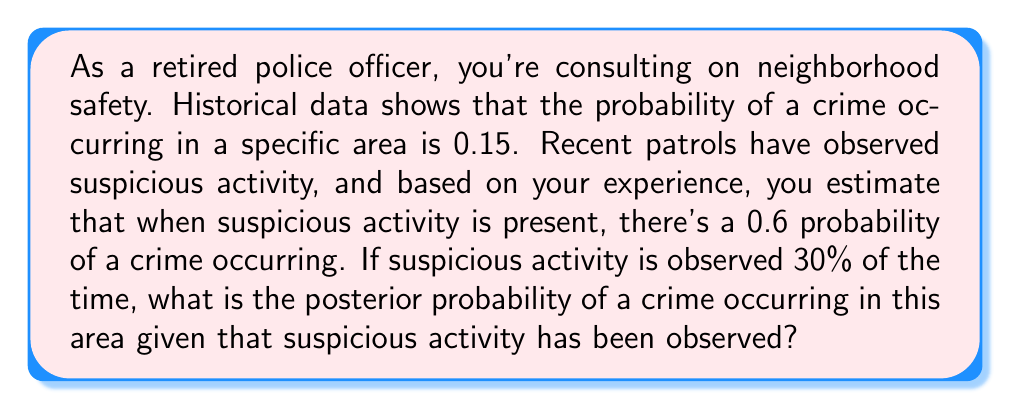Can you solve this math problem? Let's approach this problem using Bayes' theorem:

1) Define our events:
   C: Crime occurs
   S: Suspicious activity observed

2) Given information:
   P(C) = 0.15 (prior probability of crime)
   P(S|C) = 0.6 (probability of suspicious activity given a crime occurs)
   P(S) = 0.3 (probability of suspicious activity)

3) We need to find P(C|S) (posterior probability of crime given suspicious activity)

4) Bayes' theorem states:

   $$ P(C|S) = \frac{P(S|C) \cdot P(C)}{P(S)} $$

5) We have P(S|C), P(C), and P(S). Let's plug these into the formula:

   $$ P(C|S) = \frac{0.6 \cdot 0.15}{0.3} $$

6) Simplify:
   $$ P(C|S) = \frac{0.09}{0.3} = 0.3 $$

Therefore, the posterior probability of a crime occurring given that suspicious activity has been observed is 0.3 or 30%.
Answer: 0.3 or 30% 